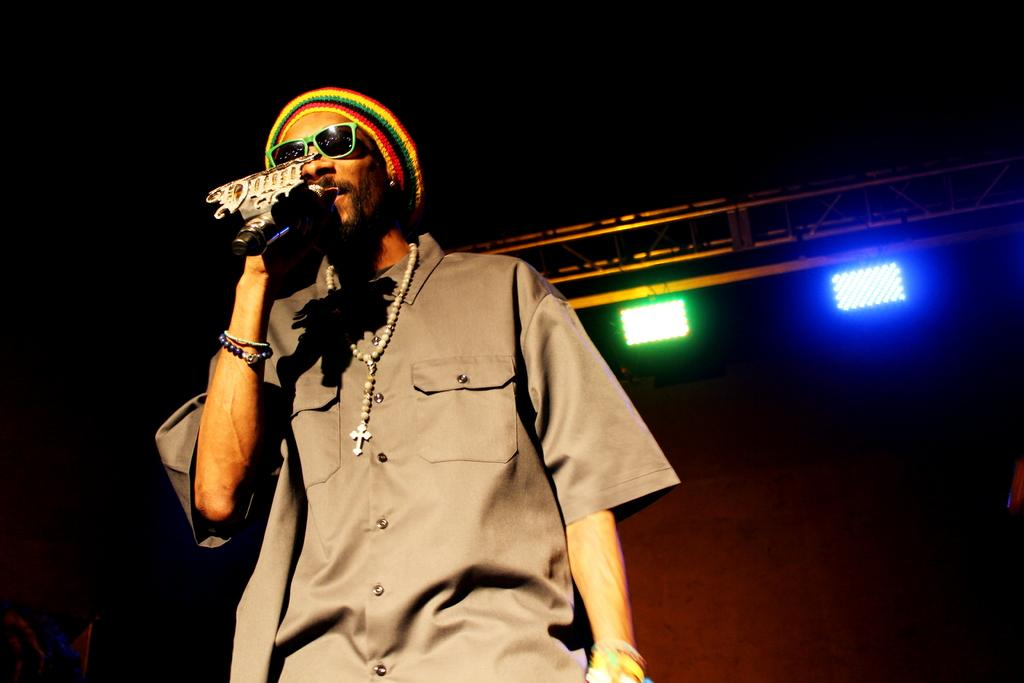What can be seen in the image? There is a person in the image. What accessories is the person wearing? The person is wearing a rosary, specs, a cap, and bracelets. What is the person holding in the image? The person is holding a mic. What can be seen in the background of the image? There are lights on stands in the background of the image. How many hands does the person have in the image? The person has two hands in the image, but we cannot count them based on the image alone. Is there a spy present in the image? There is no mention of a spy in the provided facts, and no such figure is visible in the image. 